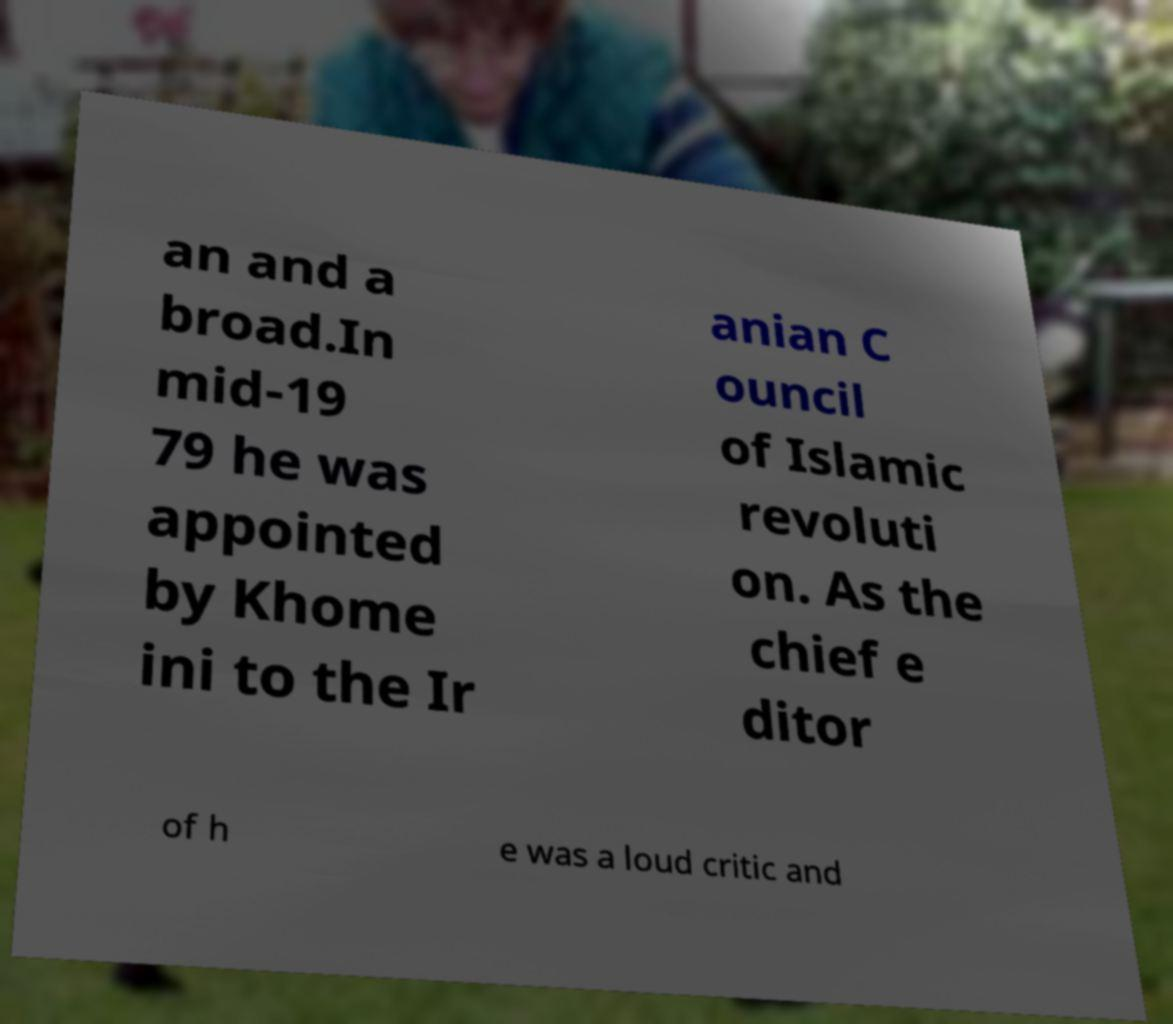For documentation purposes, I need the text within this image transcribed. Could you provide that? an and a broad.In mid-19 79 he was appointed by Khome ini to the Ir anian C ouncil of Islamic revoluti on. As the chief e ditor of h e was a loud critic and 